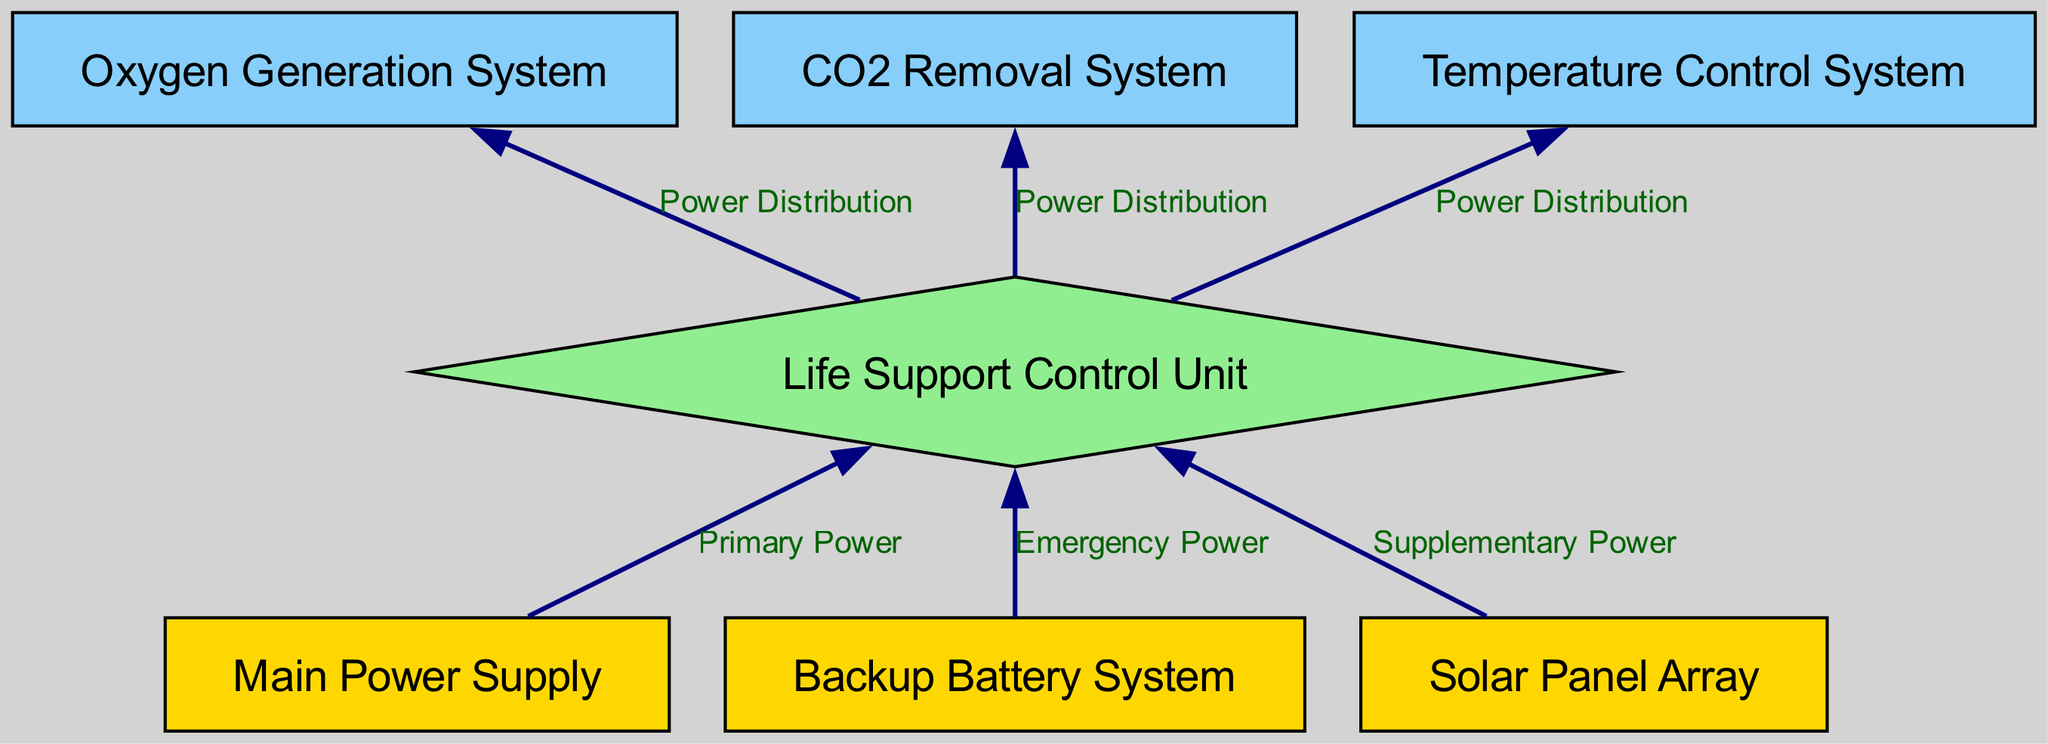What is the total number of nodes in the diagram? The diagram lists various components of the life support electrical systems, which are represented as nodes. Counting each of the nodes in the provided data shows there are 7 nodes in total.
Answer: 7 Which node represents the emergency power source? The diagram identifies the "Backup Battery System" as a key component that provides emergency power to the Life Support Control Unit, indicated by the edge labeled "Emergency Power."
Answer: Backup Battery System How many edges are connected to the Life Support Control Unit? The Life Support Control Unit is connected to three systems: the Oxygen Generation System, the CO2 Removal System, and the Temperature Control System, indicating that there are three edges leading from this node.
Answer: 3 Which node is connected to the solar panel array? The edge labeled "Supplementary Power" indicates the connection from the Solar Panel Array to the Life Support Control Unit, as it provides supplementary power to this node.
Answer: Life Support Control Unit What type of node is the Life Support Control Unit? In the diagram, the Life Support Control Unit is represented as a diamond-shaped node, indicating its role as a central control mechanism that receives power from multiple sources.
Answer: Diamond If the main power supply fails, which pathway can still provide power? In the event of a failure of the main power supply, the Backup Battery System and the Solar Panel Array are alternative pathways that can still supply power to the Life Support Control Unit, ensuring redundancy in the system.
Answer: Backup Battery System, Solar Panel Array How many power distribution edges lead from the Life Support Control Unit? The Life Support Control Unit normally distributes power to three systems: the Oxygen Generation System, the CO2 Removal System, and the Temperature Control System. Each connection signifies a power distribution edge, totaling three edges.
Answer: 3 What is the primary power source for the Life Support Control Unit? The "Main Power Supply" serves as the primary power source indicated by the directed edge labeled "Primary Power," directly linking it to the Life Support Control Unit.
Answer: Main Power Supply Which systems are reliant on the power distribution from the Life Support Control Unit? The Life Support Control Unit distributes power to the Oxygen Generation System, CO2 Removal System, and Temperature Control System, meaning all three are dependent on this power distribution to function properly.
Answer: Oxygen Generation System, CO2 Removal System, Temperature Control System 